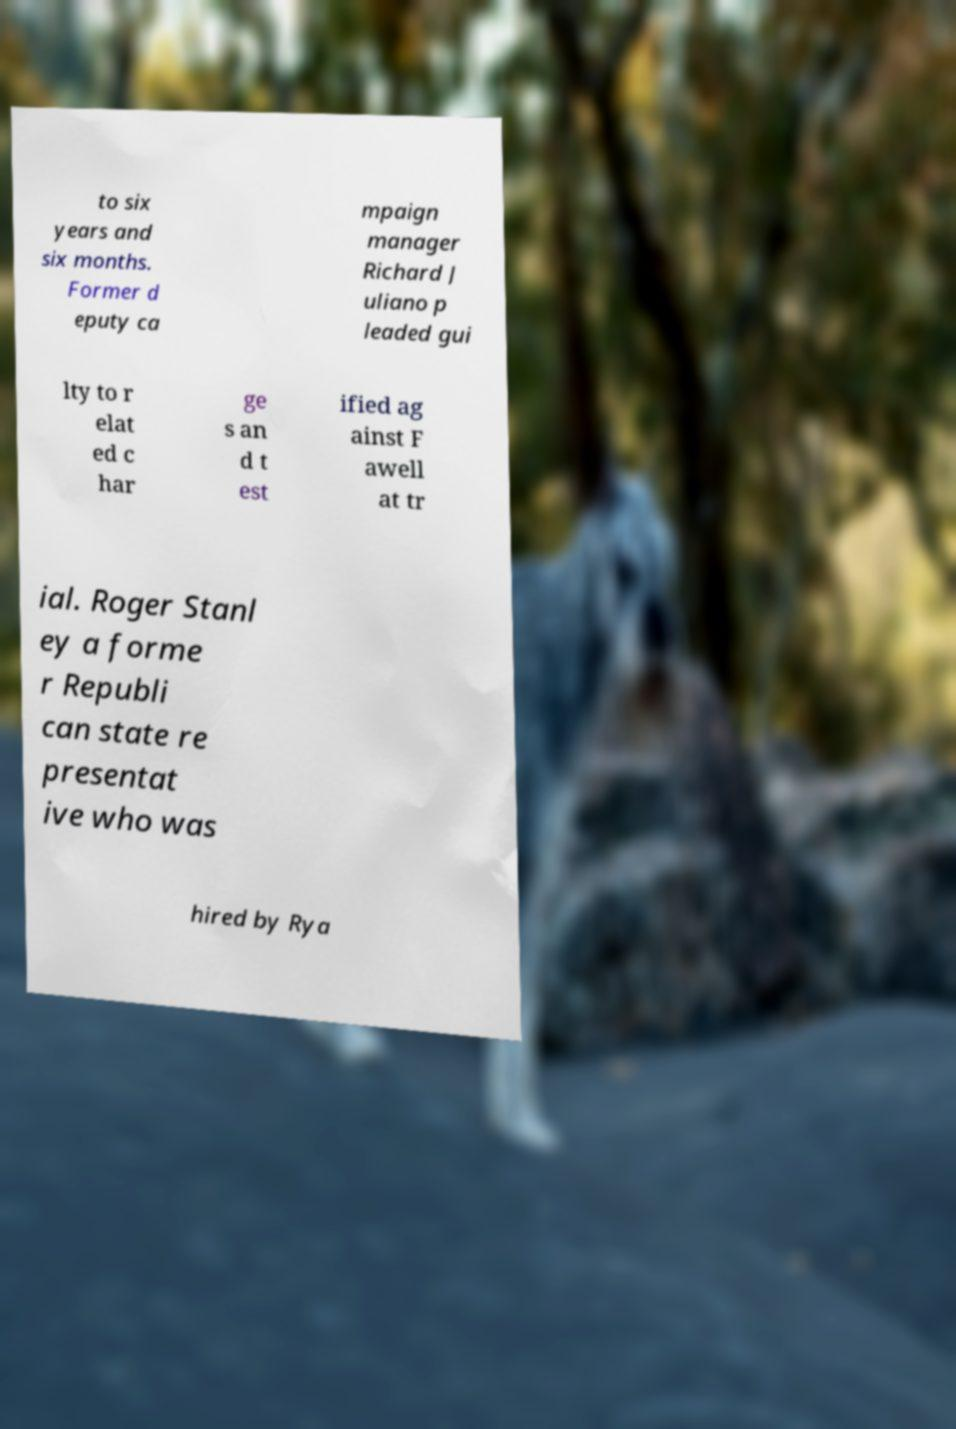Could you extract and type out the text from this image? to six years and six months. Former d eputy ca mpaign manager Richard J uliano p leaded gui lty to r elat ed c har ge s an d t est ified ag ainst F awell at tr ial. Roger Stanl ey a forme r Republi can state re presentat ive who was hired by Rya 